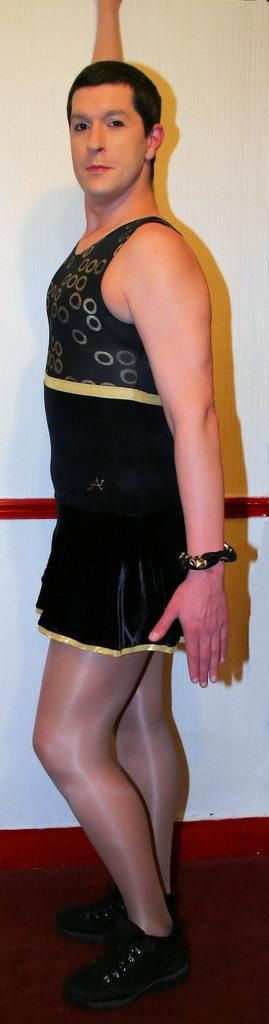What is the main subject in the image? There is a person standing in the front of the image. What can be seen behind the person in the image? There is a wall in the background of the image. What flavor of snakes can be seen sleeping on the wall in the image? There are no snakes present in the image, and therefore no flavors or sleeping snakes can be observed. 